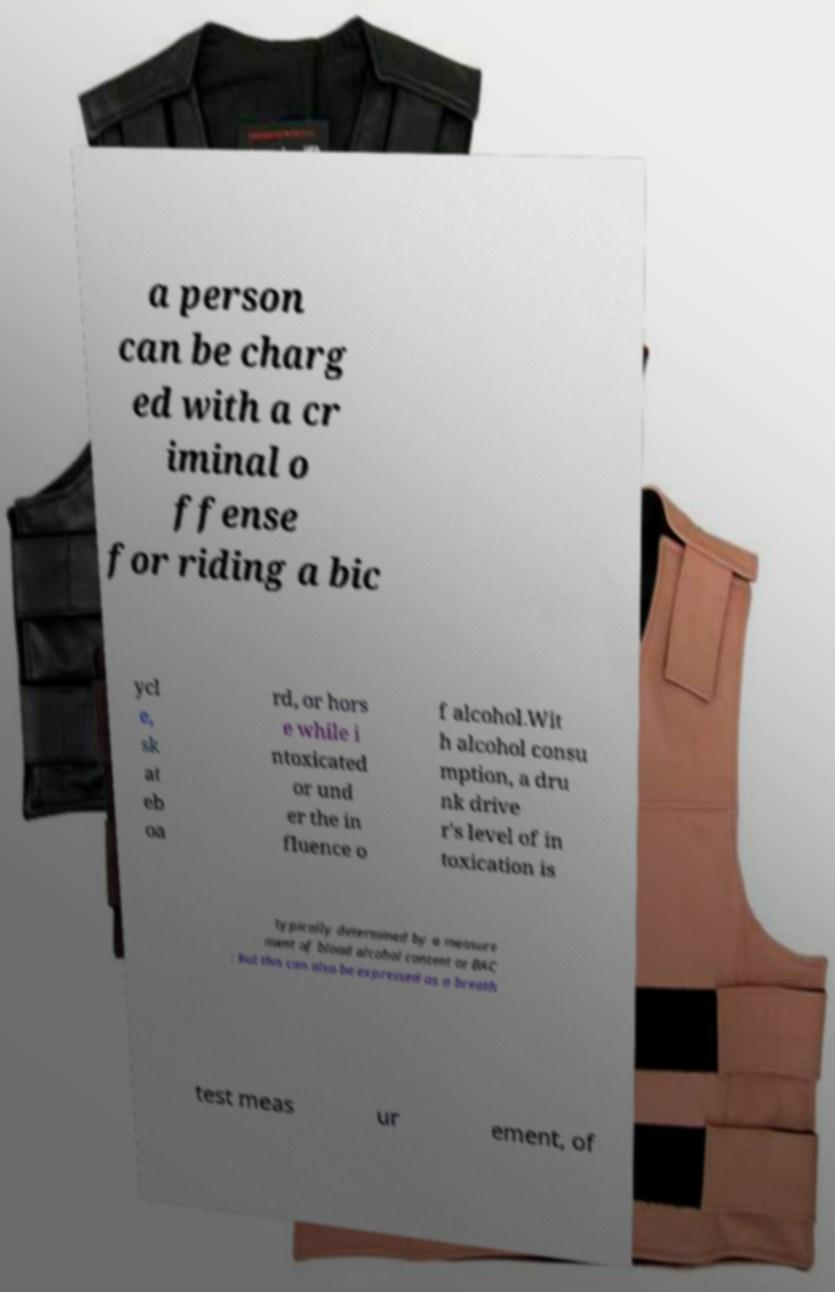For documentation purposes, I need the text within this image transcribed. Could you provide that? a person can be charg ed with a cr iminal o ffense for riding a bic ycl e, sk at eb oa rd, or hors e while i ntoxicated or und er the in fluence o f alcohol.Wit h alcohol consu mption, a dru nk drive r's level of in toxication is typically determined by a measure ment of blood alcohol content or BAC ; but this can also be expressed as a breath test meas ur ement, of 